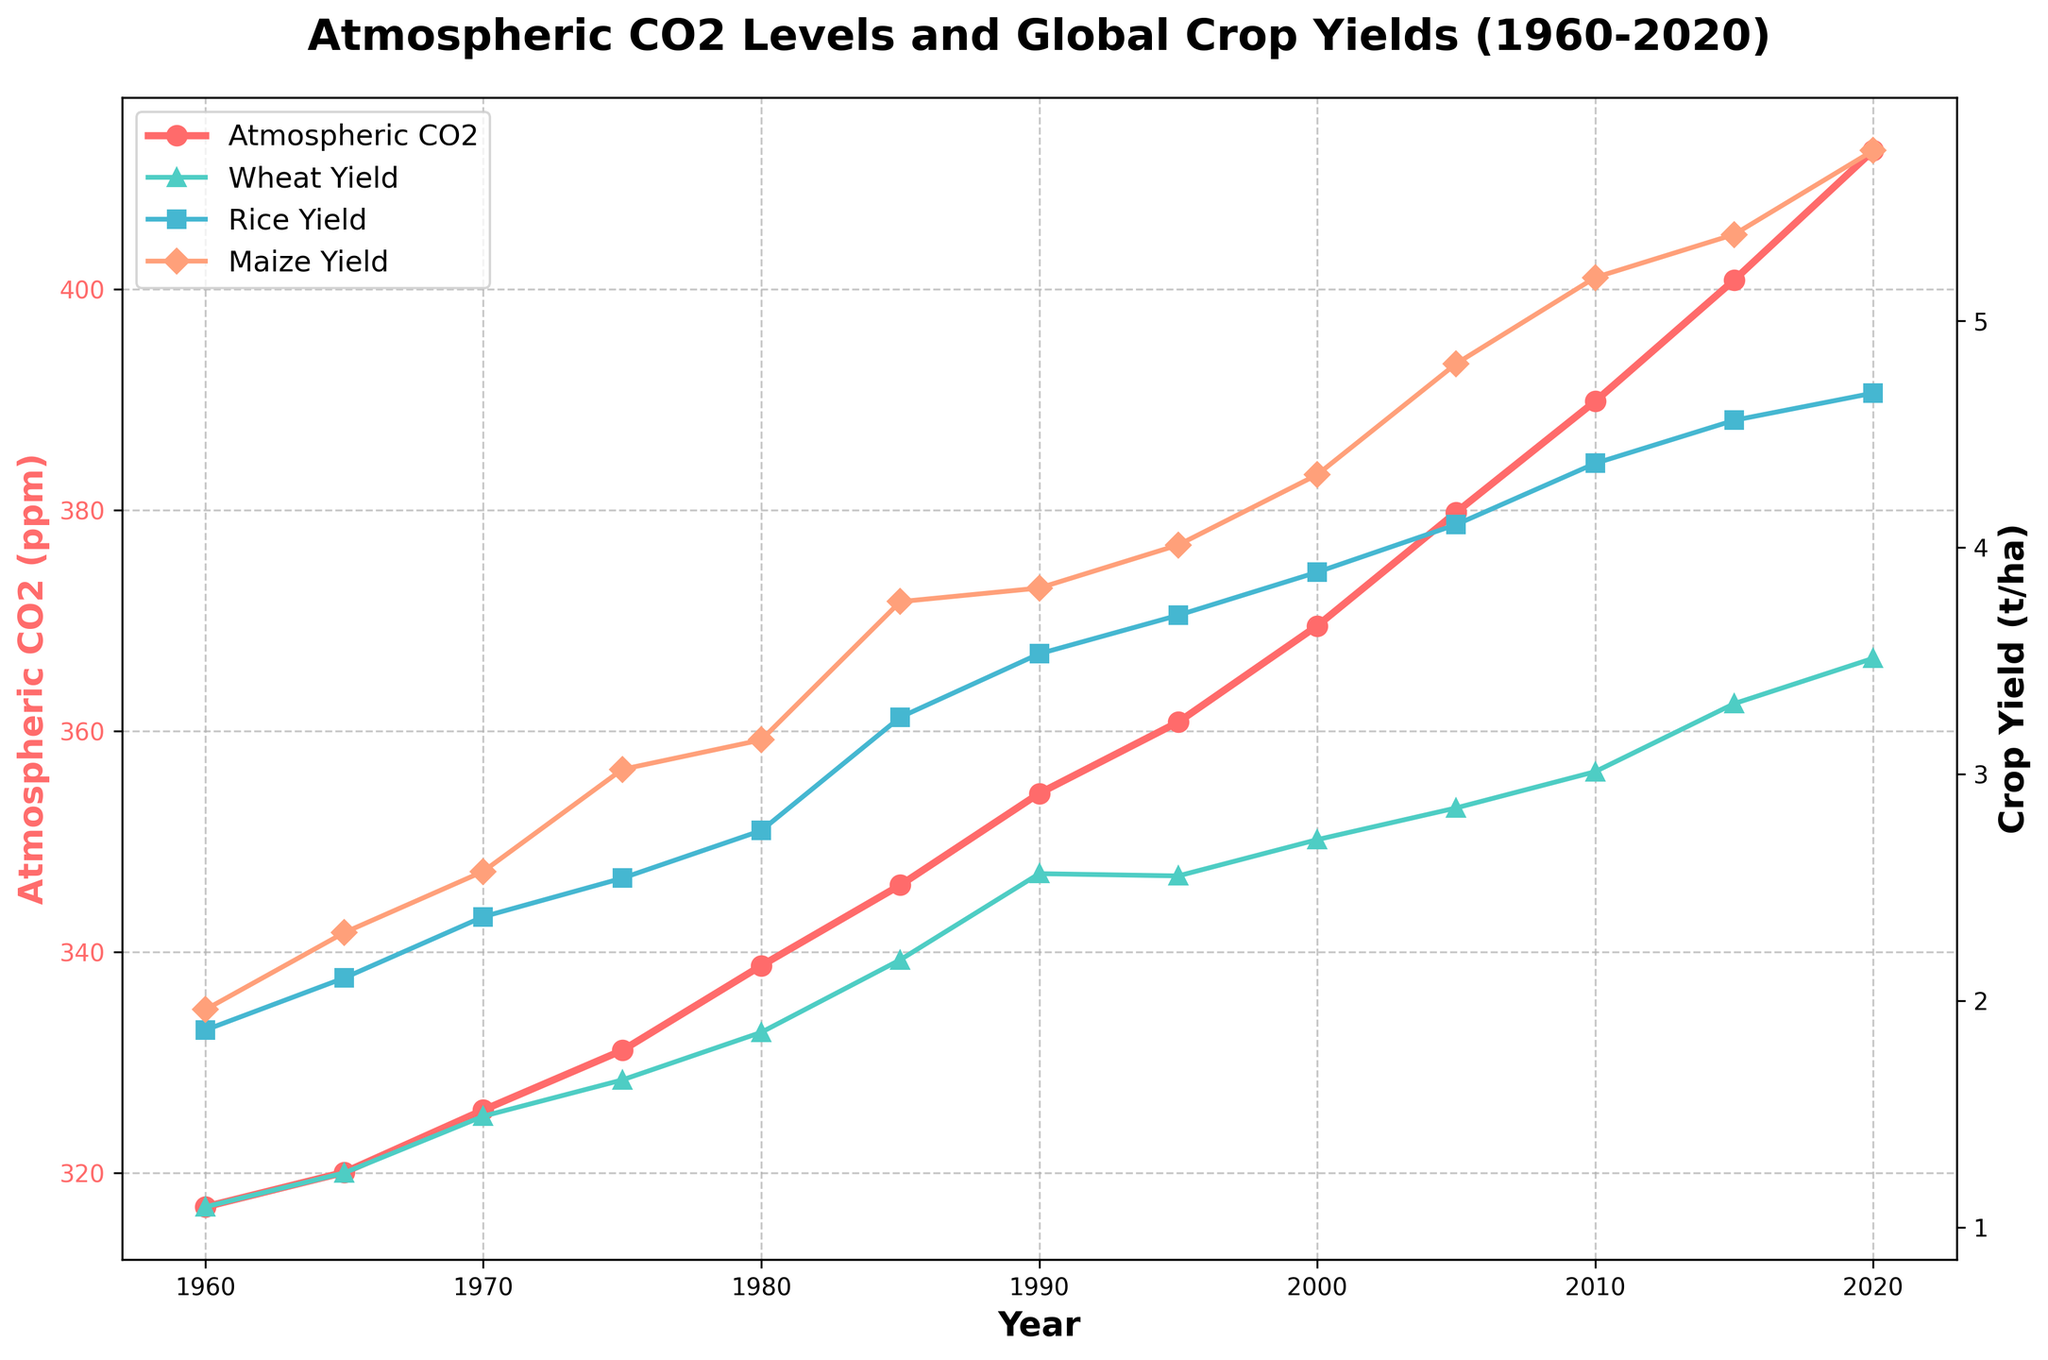What is the difference in Atmospheric CO2 levels between 1960 and 2020? To calculate the difference, subtract the value in 1960 (316.91 ppm) from the value in 2020 (412.55 ppm): 412.55 - 316.91 = 95.64 ppm.
Answer: 95.64 ppm Which year saw the highest increase in Global Wheat Yield (t/ha) compared to the previous year? Compare the increase in Global Wheat Yield for each year relative to its previous year and find the maximum value. The largest increase is between 1980 (1.86 t/ha) and 1985 (2.18 t/ha), with an increase of 2.18 - 1.86 = 0.32 t/ha.
Answer: 1985 How has the trend in Global Rice Yield changed compared to the trend in Atmospheric CO2 levels from 1980 to 2020? Analyze the slopes of the lines for Global Rice Yield and Atmospheric CO2 levels from 1980 (338.75 ppm for CO2, 2.75 t/ha for Rice Yield) to 2020 (412.55 ppm for CO2, 4.68 t/ha for Rice Yield). Both show an upward trend, indicating an increase over time.
Answer: Both have increased In which decade did Global Maize Yield start showing significant increases? Look at the plot for Global Maize Yield and identify where the yield starts increasing more steeply. This begins around 1970-1980, going from 2.57 t/ha in 1970 to 3.76 t/ha in 1985.
Answer: 1970s What is the average Global Rice Yield (t/ha) between 2000 and 2020? To calculate the average, sum the values for the years 2000 (3.89 t/ha), 2005 (4.10 t/ha), 2010 (4.37 t/ha), 2015 (4.56 t/ha), and 2020 (4.68 t/ha), then divide by the number of years: (3.89 + 4.10 + 4.37 + 4.56 + 4.68) / 5 = 4.32 t/ha.
Answer: 4.32 t/ha Between which consecutive years did Atmospheric CO2 levels show the smallest increase? Compare the increase in Atmospheric CO2 levels year over year and find the smallest difference: The smallest is between 1960 (316.91 ppm) and 1965 (320.04 ppm) with an increase of 320.04 - 316.91 = 3.13 ppm.
Answer: 1960 and 1965 Does the trend in Global Wheat Yield appear to be correlated with the trend in Atmospheric CO2 levels? Observe the trends in both sets of data over the years. Both show a general increase over time, suggesting a positive correlation.
Answer: Yes What is the overall increase in Global Maize Yield (t/ha) from 1960 to 2020? Subtract the yield in 1960 (1.96 t/ha) from the yield in 2020 (5.75 t/ha): 5.75 - 1.96 = 3.79 t/ha.
Answer: 3.79 t/ha 